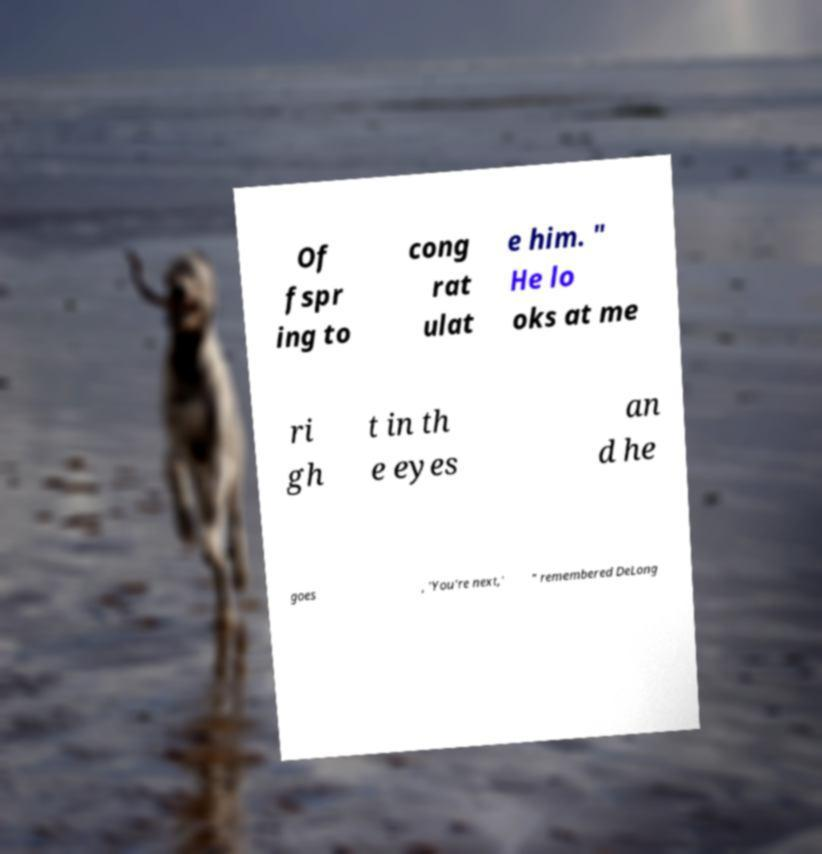Could you extract and type out the text from this image? Of fspr ing to cong rat ulat e him. " He lo oks at me ri gh t in th e eyes an d he goes , 'You're next,' " remembered DeLong 